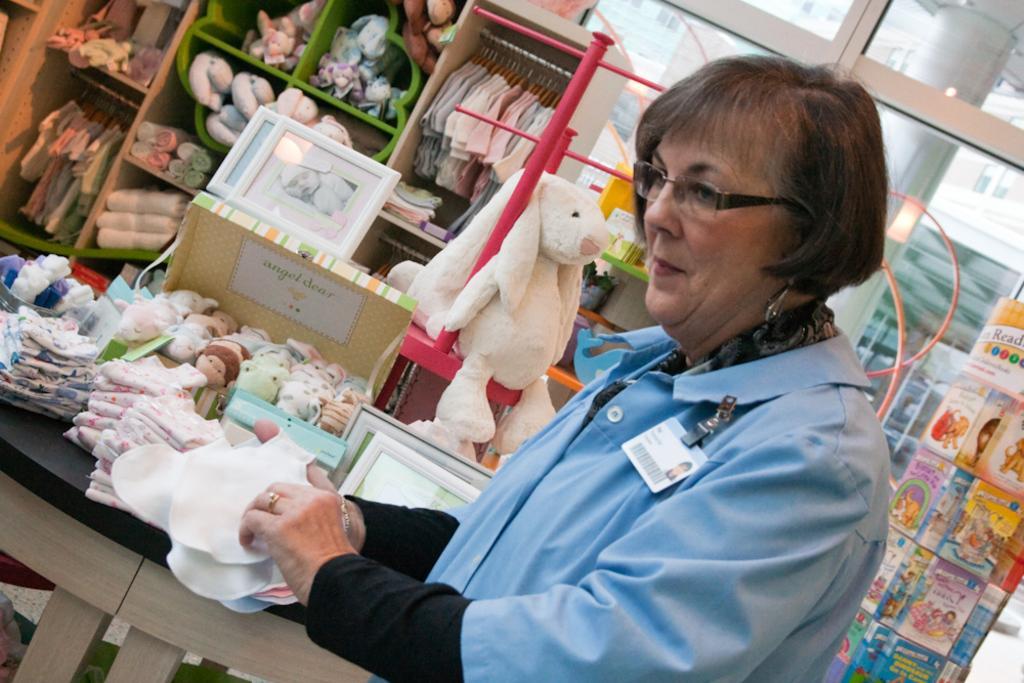Can you describe this image briefly? In this image, I can see the woman standing and holding the napkins. This is the table with the box of tiny toys, clothes, frames and few other things on it. I can see the clothes hanging to the hangers and the toys, which are kept in the racks. This looks like a glass door. On the right side of the image, I think these are the books. 